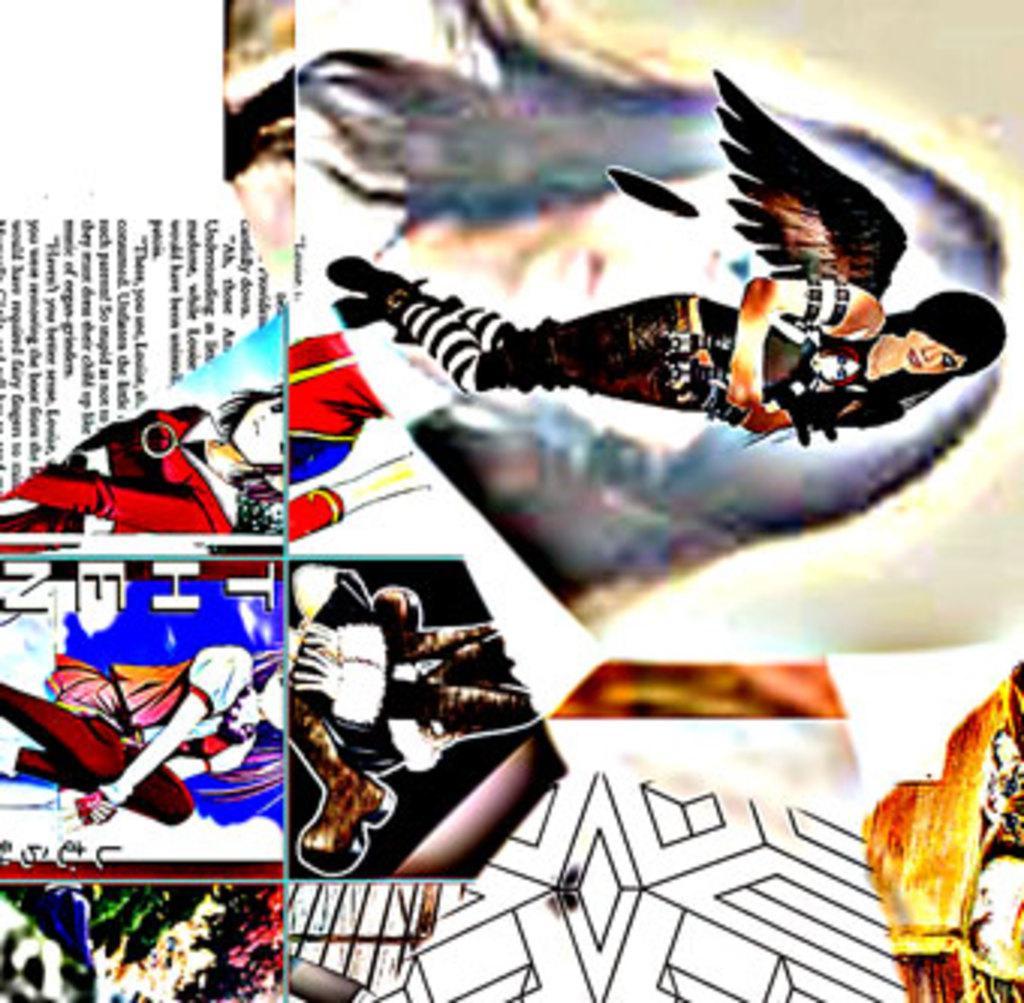Describe this image in one or two sentences. There is a collage image different pictures contains depiction of persons, designs and some text. 